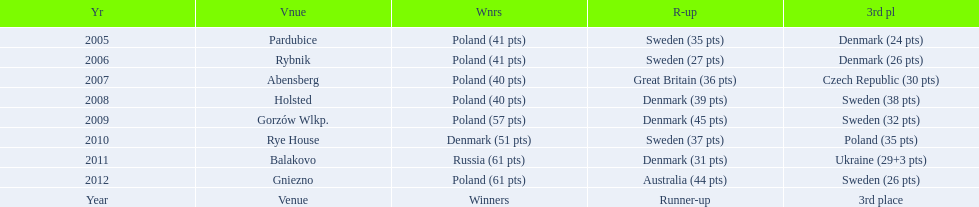After 2008 how many points total were scored by winners? 230. Could you parse the entire table? {'header': ['Yr', 'Vnue', 'Wnrs', 'R-up', '3rd pl'], 'rows': [['2005', 'Pardubice', 'Poland (41 pts)', 'Sweden (35 pts)', 'Denmark (24 pts)'], ['2006', 'Rybnik', 'Poland (41 pts)', 'Sweden (27 pts)', 'Denmark (26 pts)'], ['2007', 'Abensberg', 'Poland (40 pts)', 'Great Britain (36 pts)', 'Czech Republic (30 pts)'], ['2008', 'Holsted', 'Poland (40 pts)', 'Denmark (39 pts)', 'Sweden (38 pts)'], ['2009', 'Gorzów Wlkp.', 'Poland (57 pts)', 'Denmark (45 pts)', 'Sweden (32 pts)'], ['2010', 'Rye House', 'Denmark (51 pts)', 'Sweden (37 pts)', 'Poland (35 pts)'], ['2011', 'Balakovo', 'Russia (61 pts)', 'Denmark (31 pts)', 'Ukraine (29+3 pts)'], ['2012', 'Gniezno', 'Poland (61 pts)', 'Australia (44 pts)', 'Sweden (26 pts)'], ['Year', 'Venue', 'Winners', 'Runner-up', '3rd place']]} 